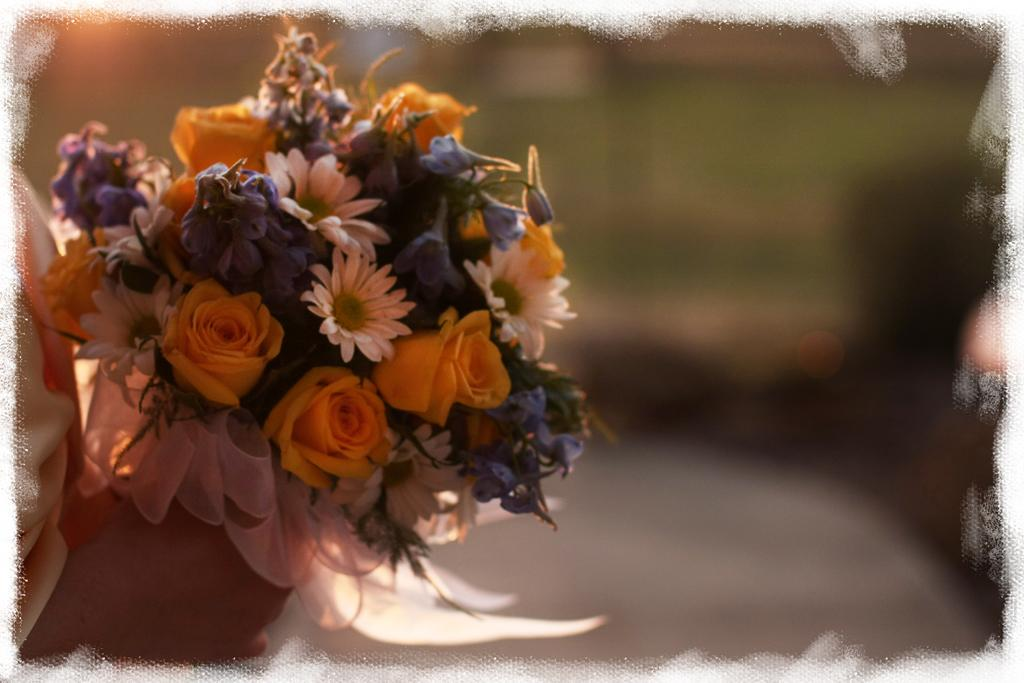What is the main subject in the foreground of the image? There is a person in the foreground of the image. What is the person holding in the image? The person is holding flowers. Can you describe the background of the image? There are objects in the background of the image. What type of ear can be seen on the person in the image? There is no ear visible on the person in the image, as the person's face is not shown. What kind of jewel is the person wearing in the image? There is no mention of any jewelry being worn by the person in the image. 